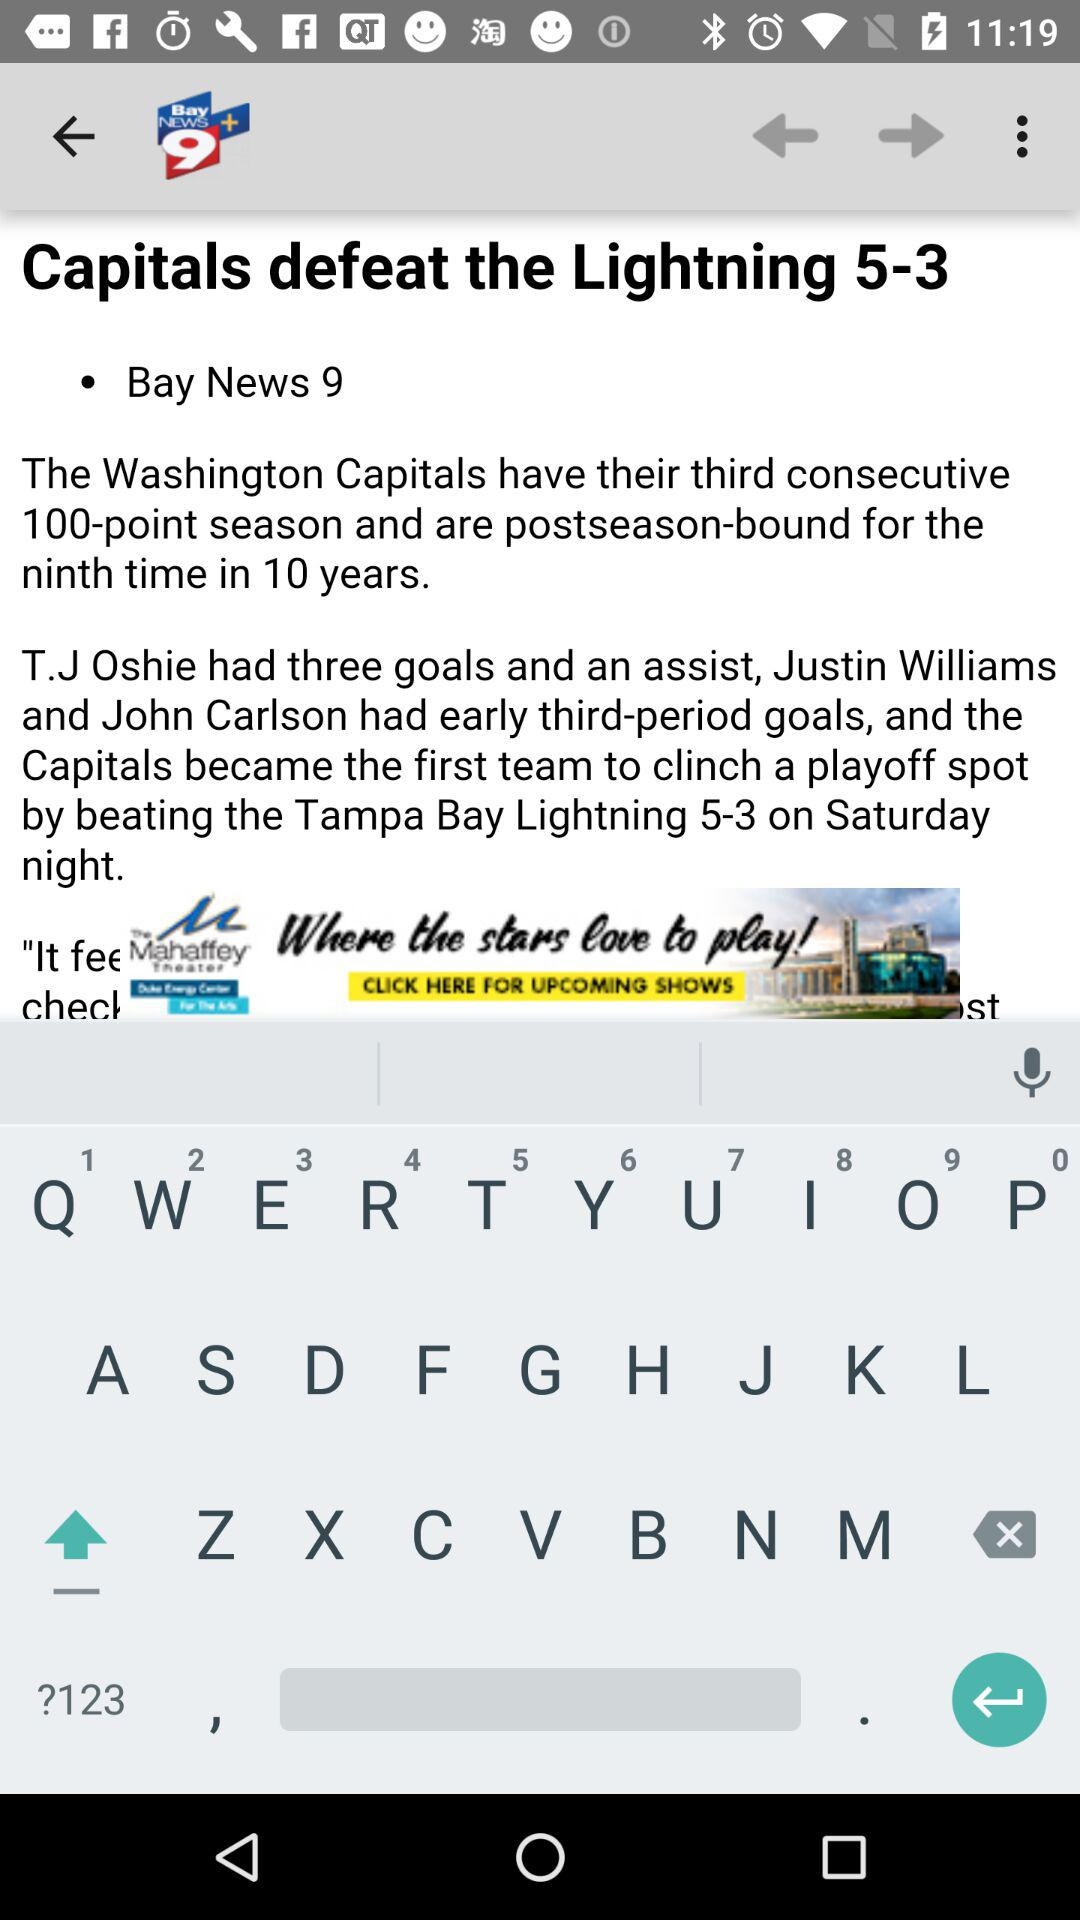When will the "Capitals" play next?
When the provided information is insufficient, respond with <no answer>. <no answer> 